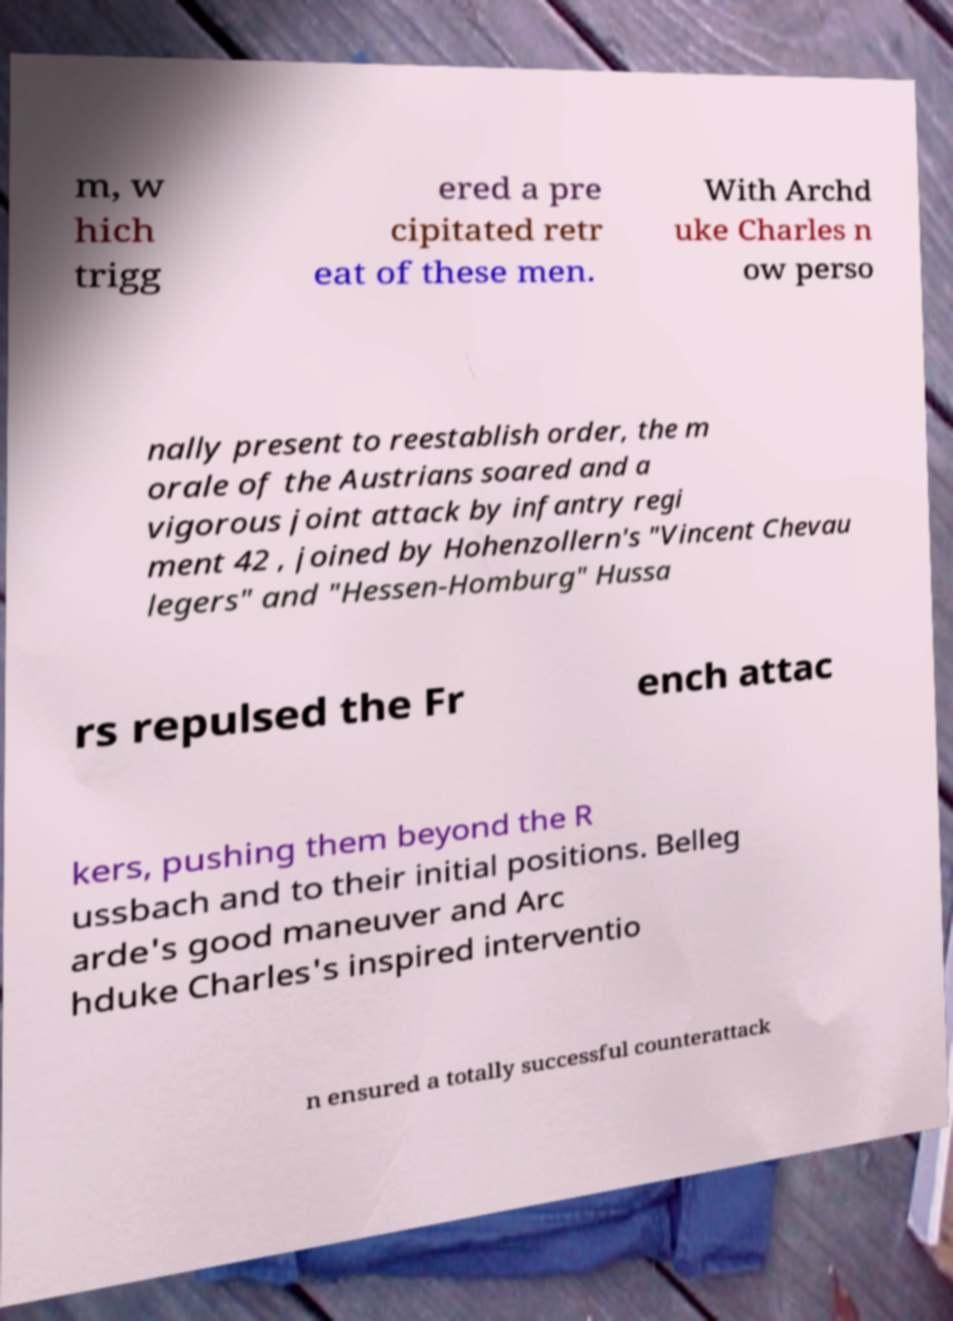Could you extract and type out the text from this image? m, w hich trigg ered a pre cipitated retr eat of these men. With Archd uke Charles n ow perso nally present to reestablish order, the m orale of the Austrians soared and a vigorous joint attack by infantry regi ment 42 , joined by Hohenzollern's "Vincent Chevau legers" and "Hessen-Homburg" Hussa rs repulsed the Fr ench attac kers, pushing them beyond the R ussbach and to their initial positions. Belleg arde's good maneuver and Arc hduke Charles's inspired interventio n ensured a totally successful counterattack 